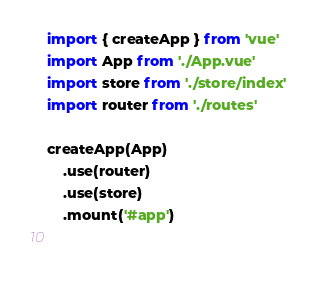Convert code to text. <code><loc_0><loc_0><loc_500><loc_500><_JavaScript_>import { createApp } from 'vue'
import App from './App.vue'
import store from './store/index'
import router from './routes'

createApp(App)
    .use(router)
    .use(store)
    .mount('#app')

      </code> 